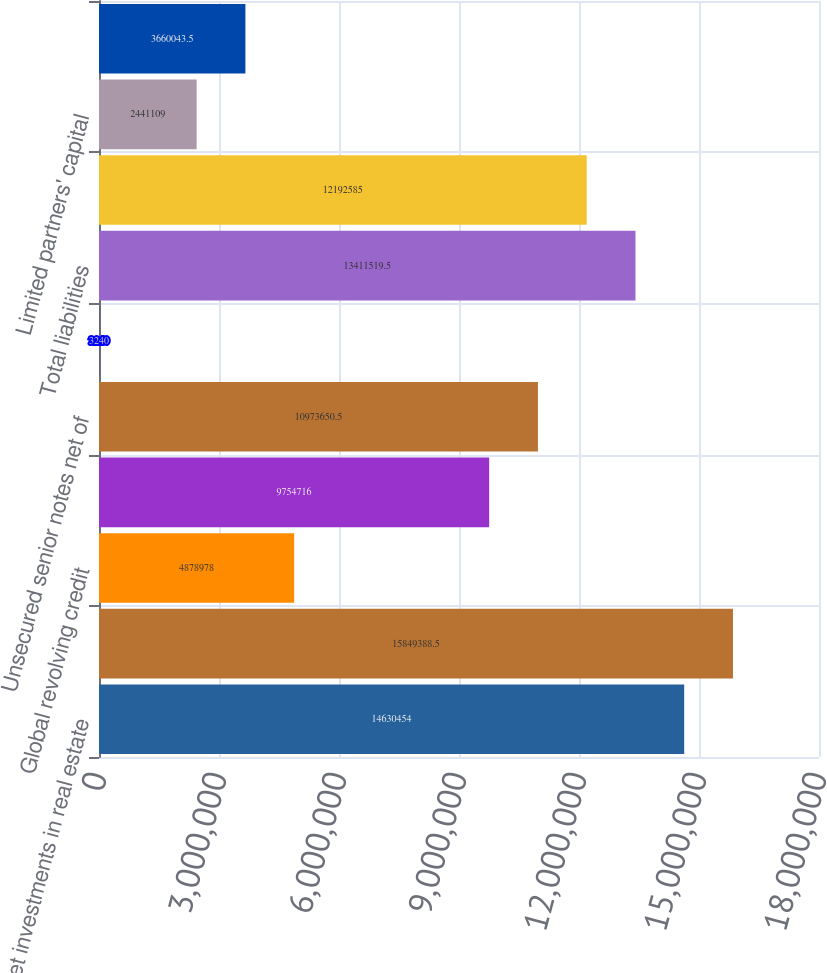<chart> <loc_0><loc_0><loc_500><loc_500><bar_chart><fcel>Net investments in real estate<fcel>Total assets<fcel>Global revolving credit<fcel>Unsecured term loan<fcel>Unsecured senior notes net of<fcel>Mortgages and other secured<fcel>Total liabilities<fcel>General partner's capital<fcel>Limited partners' capital<fcel>Accumulated other<nl><fcel>1.46305e+07<fcel>1.58494e+07<fcel>4.87898e+06<fcel>9.75472e+06<fcel>1.09737e+07<fcel>3240<fcel>1.34115e+07<fcel>1.21926e+07<fcel>2.44111e+06<fcel>3.66004e+06<nl></chart> 